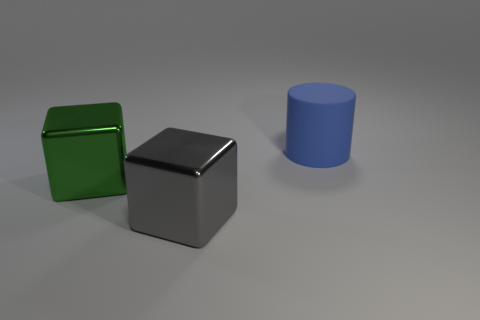Add 3 cyan matte cylinders. How many objects exist? 6 Subtract all blocks. How many objects are left? 1 Subtract 0 purple cubes. How many objects are left? 3 Subtract all small gray rubber cylinders. Subtract all big metallic cubes. How many objects are left? 1 Add 3 things. How many things are left? 6 Add 2 small cyan metallic spheres. How many small cyan metallic spheres exist? 2 